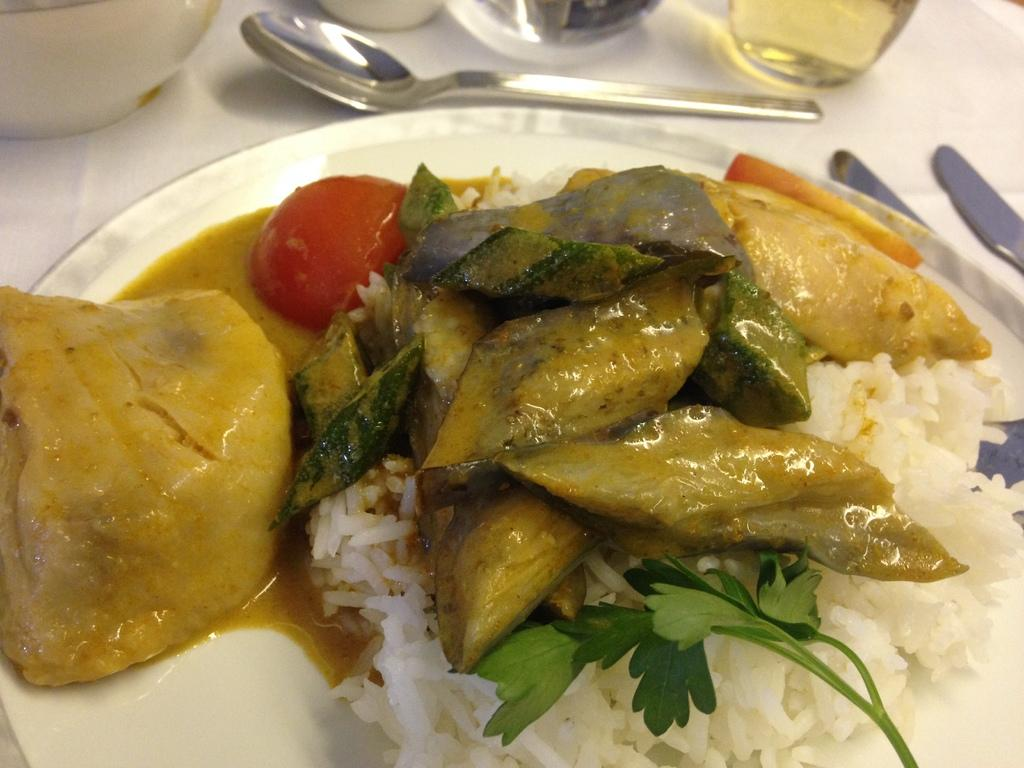What is the main subject of the image? The image is a zoomed in picture of food in a plate. What other objects can be seen in the background of the image? There is a bowl, a spoon, and glasses on a white surface in the background of the image. What is the income of the person who prepared the food in the image? There is no information about the income of the person who prepared the food in the image. Can you see any flies in the image? There are no flies visible in the image. 